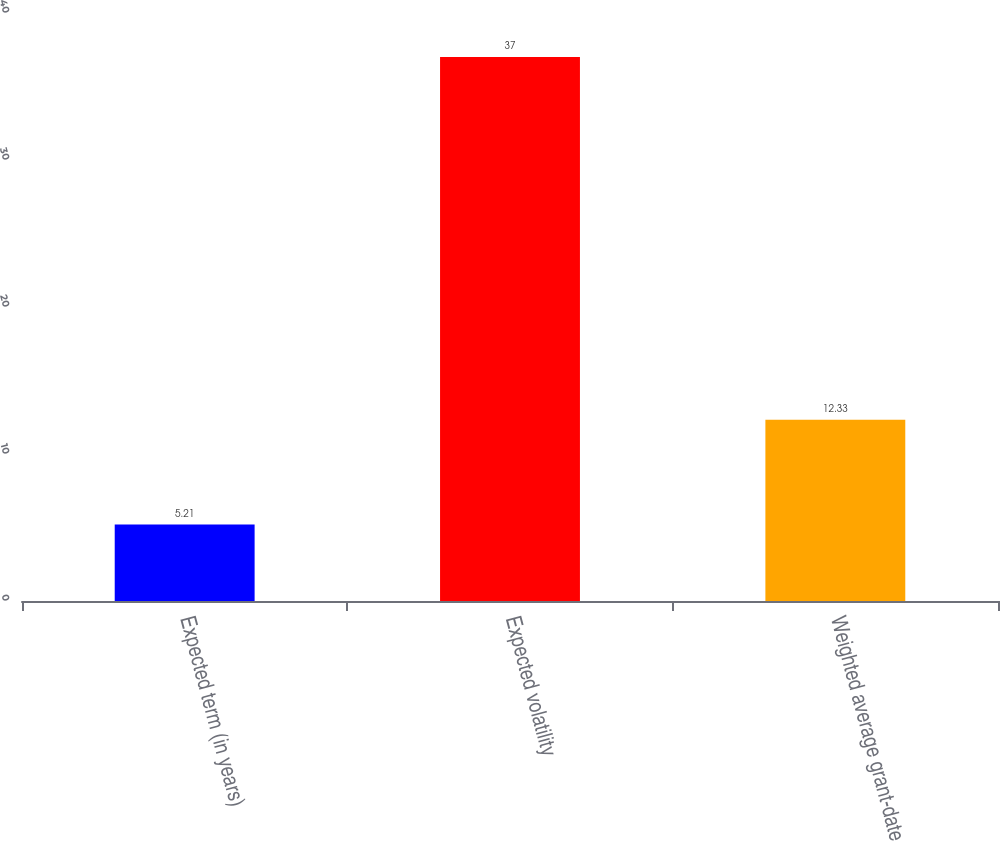Convert chart. <chart><loc_0><loc_0><loc_500><loc_500><bar_chart><fcel>Expected term (in years)<fcel>Expected volatility<fcel>Weighted average grant-date<nl><fcel>5.21<fcel>37<fcel>12.33<nl></chart> 